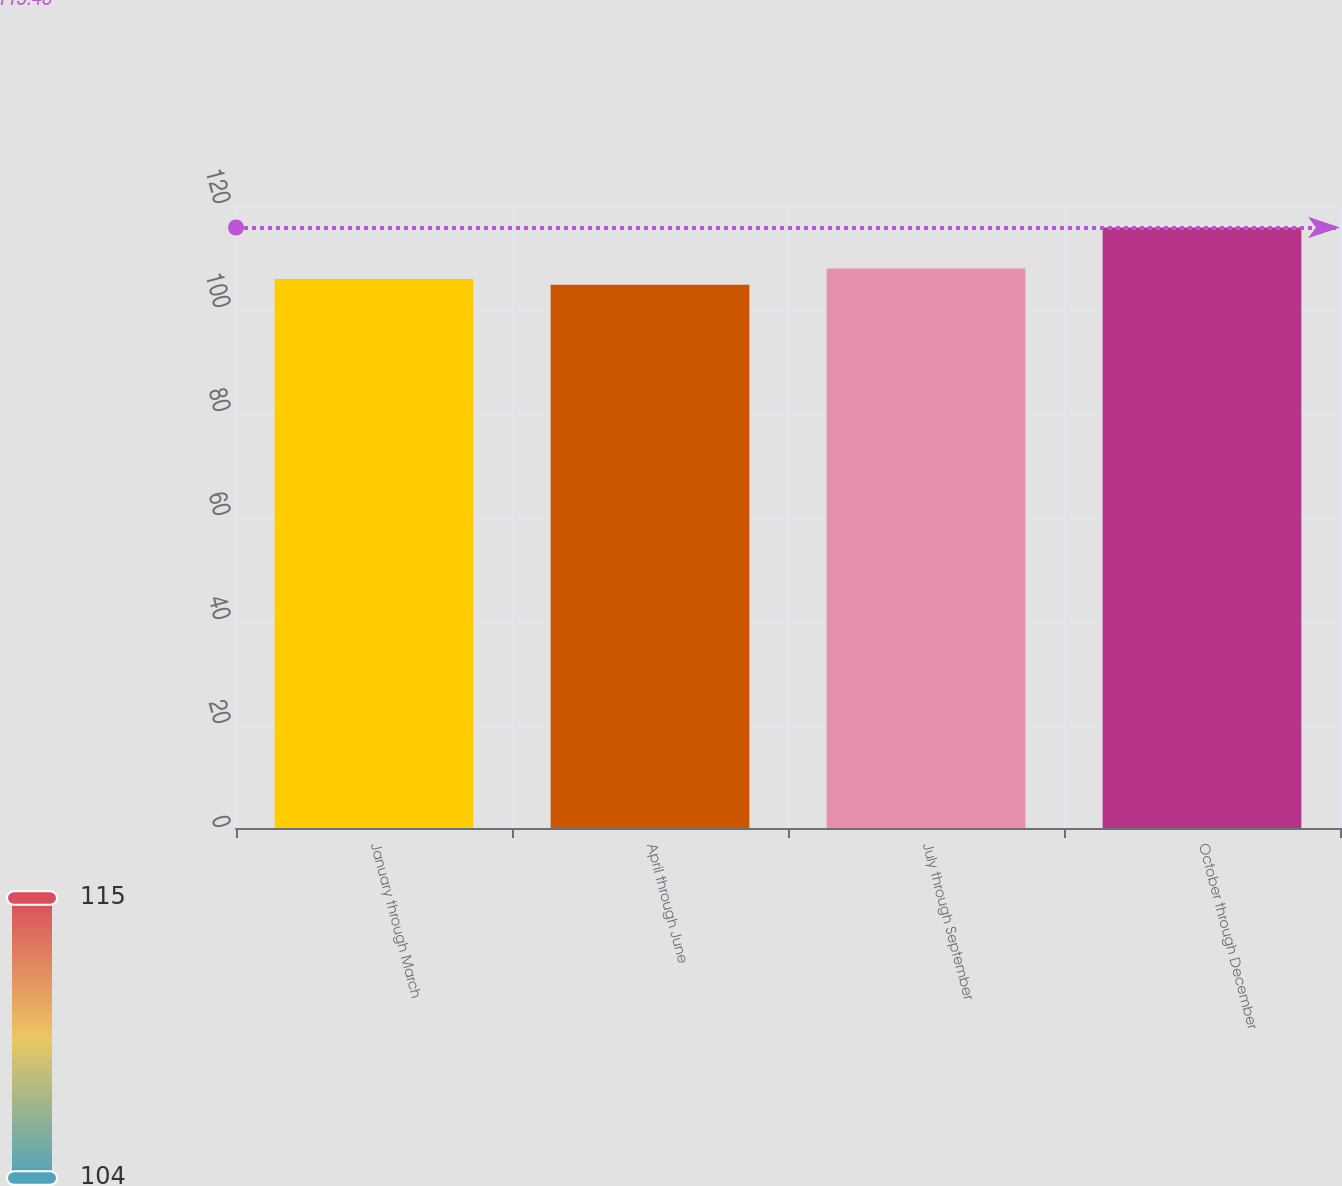Convert chart. <chart><loc_0><loc_0><loc_500><loc_500><bar_chart><fcel>January through March<fcel>April through June<fcel>July through September<fcel>October through December<nl><fcel>105.59<fcel>104.49<fcel>107.59<fcel>115.48<nl></chart> 